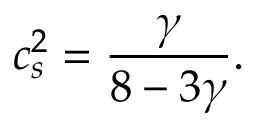Convert formula to latex. <formula><loc_0><loc_0><loc_500><loc_500>c _ { s } ^ { 2 } = \frac { \gamma } { 8 - 3 \gamma } .</formula> 